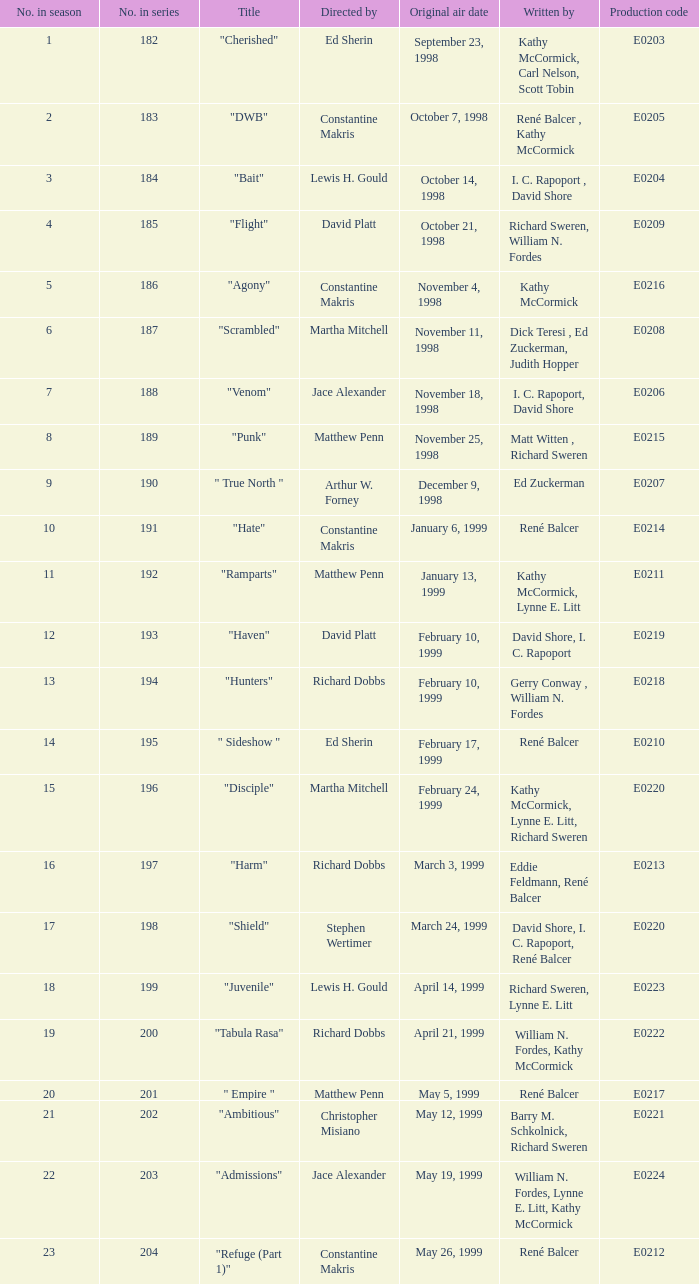What is the season number of the episode written by Matt Witten , Richard Sweren? 8.0. 